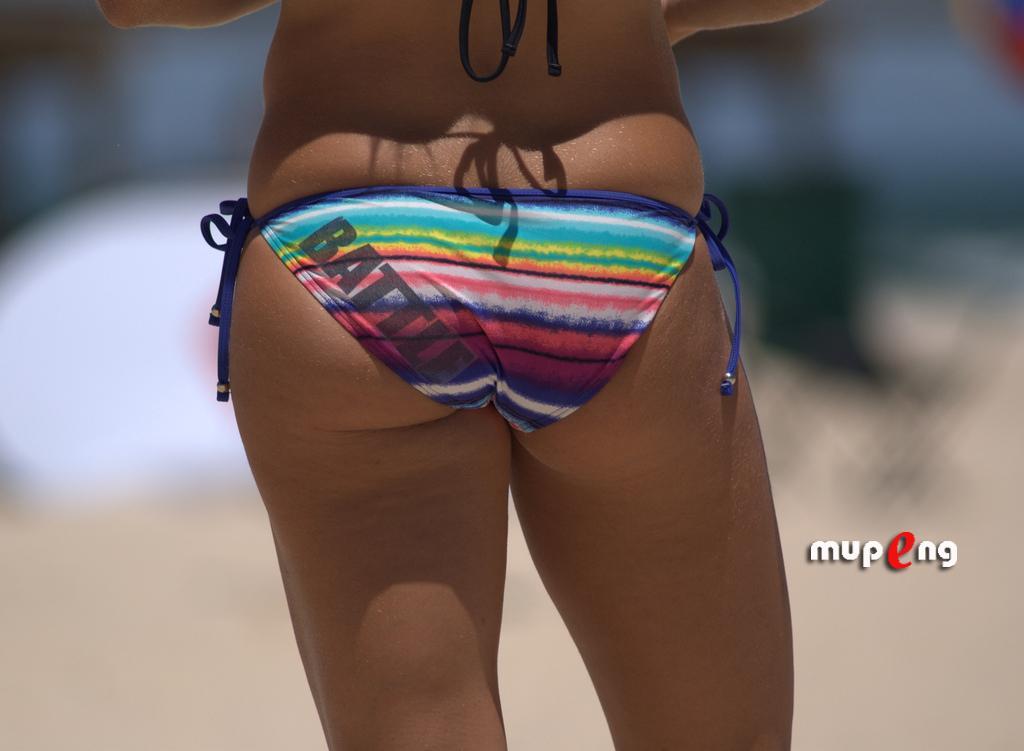Please provide a concise description of this image. In this picture we can see a person standing and in the background it is blurry. 